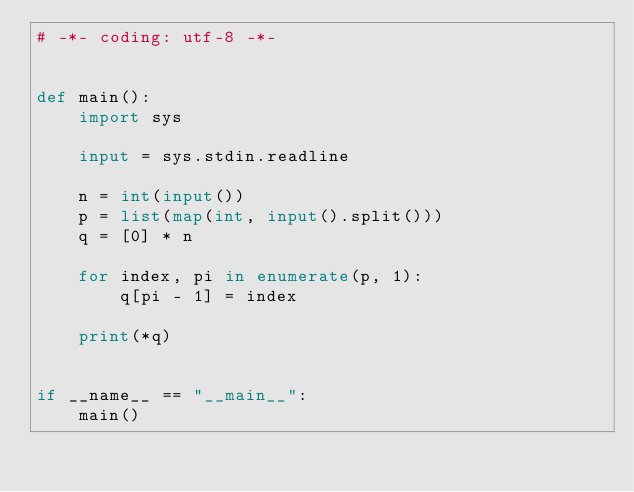Convert code to text. <code><loc_0><loc_0><loc_500><loc_500><_Python_># -*- coding: utf-8 -*-


def main():
    import sys

    input = sys.stdin.readline

    n = int(input())
    p = list(map(int, input().split()))
    q = [0] * n

    for index, pi in enumerate(p, 1):
        q[pi - 1] = index

    print(*q)


if __name__ == "__main__":
    main()
</code> 